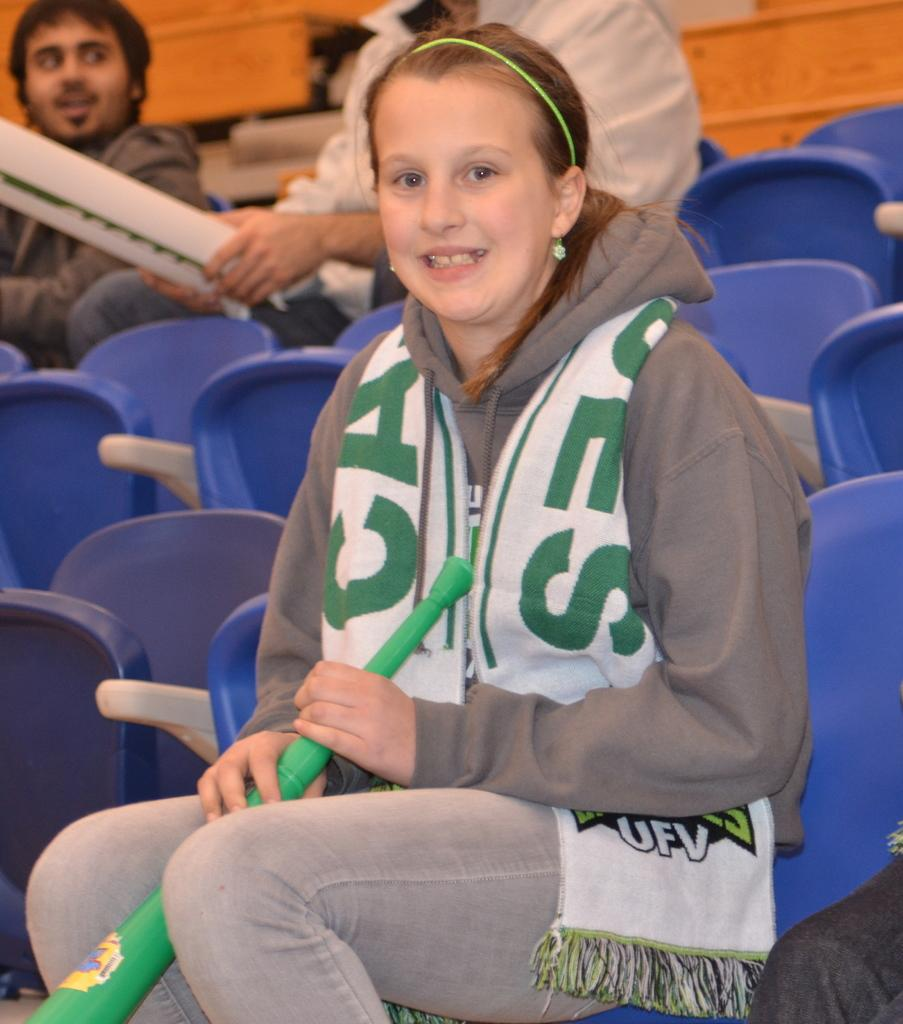<image>
Write a terse but informative summary of the picture. A girl is wearing a jacket with an UFV logo on it. 